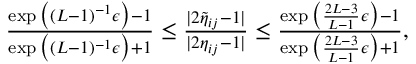Convert formula to latex. <formula><loc_0><loc_0><loc_500><loc_500>\begin{array} { r } { \frac { \exp \left ( ( L - 1 ) ^ { - 1 } \epsilon \right ) - 1 } { \exp \left ( ( L - 1 ) ^ { - 1 } \epsilon \right ) + 1 } \leq \frac { | 2 \widetilde { \eta } _ { i j } - 1 | } { | 2 \eta _ { i j } - 1 | } \leq \frac { \exp \left ( \frac { 2 L - 3 } { L - 1 } \epsilon \right ) - 1 } { \exp \left ( \frac { 2 L - 3 } { L - 1 } \epsilon \right ) + 1 } , } \end{array}</formula> 